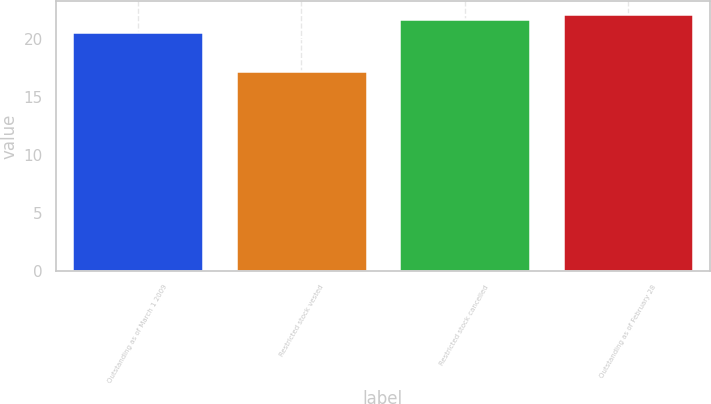Convert chart to OTSL. <chart><loc_0><loc_0><loc_500><loc_500><bar_chart><fcel>Outstanding as of March 1 2009<fcel>Restricted stock vested<fcel>Restricted stock cancelled<fcel>Outstanding as of February 28<nl><fcel>20.55<fcel>17.25<fcel>21.65<fcel>22.13<nl></chart> 